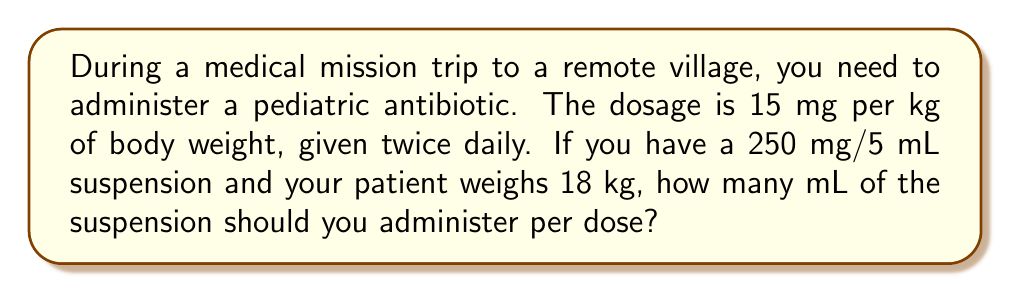Could you help me with this problem? Let's approach this step-by-step:

1) First, calculate the total dose needed for the patient:
   $$\text{Dose} = 15 \text{ mg/kg} \times 18 \text{ kg} = 270 \text{ mg}$$

2) Now, we need to determine how many mL of the suspension will deliver 270 mg.
   We can set up a proportion:

   $$\frac{250 \text{ mg}}{5 \text{ mL}} = \frac{270 \text{ mg}}{x \text{ mL}}$$

3) Cross multiply:
   $$250x = 5 \times 270$$

4) Solve for x:
   $$x = \frac{5 \times 270}{250} = \frac{1350}{250} = 5.4 \text{ mL}$$

Therefore, you should administer 5.4 mL of the suspension per dose.
Answer: 5.4 mL 